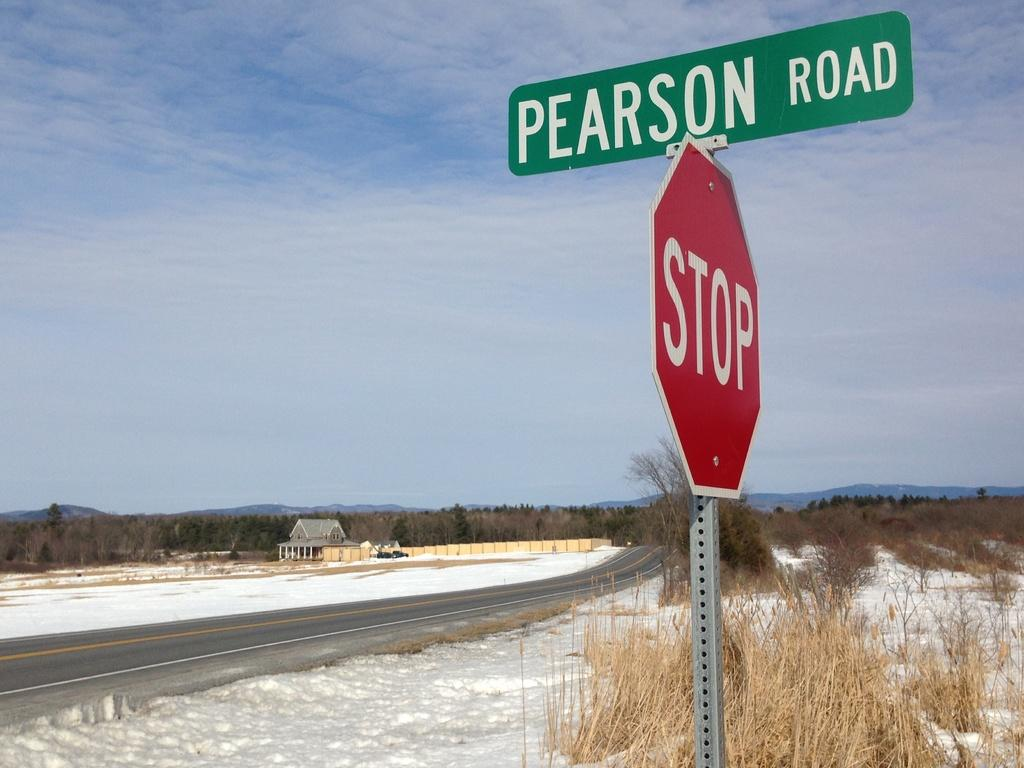Provide a one-sentence caption for the provided image. A stop sign stands at the corner of Pearson Road. 